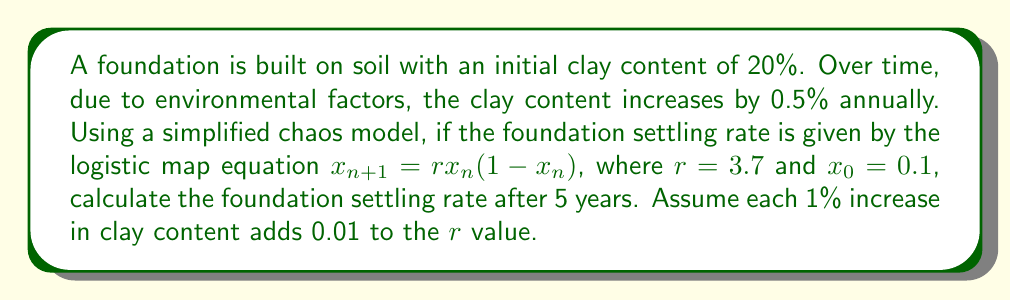What is the answer to this math problem? 1. Calculate the increase in clay content after 5 years:
   Annual increase = 0.5%
   Total increase = 0.5% × 5 years = 2.5%

2. Determine the new $r$ value:
   Initial $r = 3.7$
   Increase in $r = 2.5 × 0.01 = 0.025$
   New $r = 3.7 + 0.025 = 3.725$

3. Apply the logistic map equation for 5 iterations:
   $x_0 = 0.1$
   $x_1 = 3.725 × 0.1 × (1 - 0.1) = 0.33525$
   $x_2 = 3.725 × 0.33525 × (1 - 0.33525) = 0.82959$
   $x_3 = 3.725 × 0.82959 × (1 - 0.82959) = 0.52834$
   $x_4 = 3.725 × 0.52834 × (1 - 0.52834) = 0.92846$
   $x_5 = 3.725 × 0.92846 × (1 - 0.92846) = 0.24686$

4. The foundation settling rate after 5 years is represented by $x_5 = 0.24686$
Answer: 0.24686 